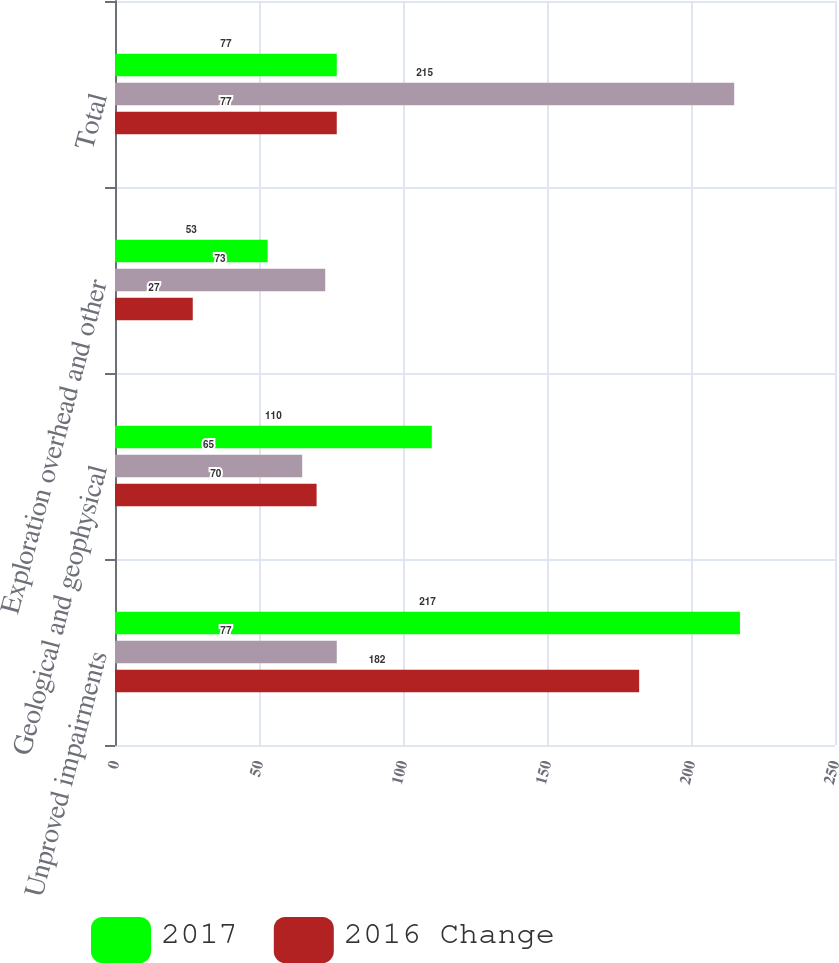Convert chart. <chart><loc_0><loc_0><loc_500><loc_500><stacked_bar_chart><ecel><fcel>Unproved impairments<fcel>Geological and geophysical<fcel>Exploration overhead and other<fcel>Total<nl><fcel>2017<fcel>217<fcel>110<fcel>53<fcel>77<nl><fcel>nan<fcel>77<fcel>65<fcel>73<fcel>215<nl><fcel>2016 Change<fcel>182<fcel>70<fcel>27<fcel>77<nl></chart> 